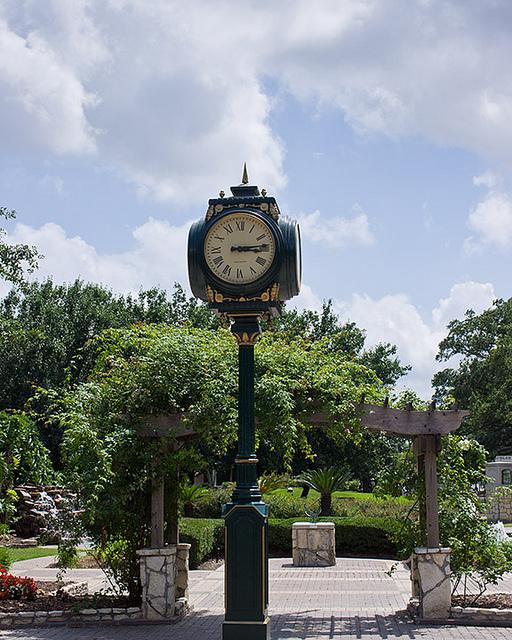What time is shown on the clock?
Be succinct. 3:15. What color are the flowers on the floor on the left of the clock?
Write a very short answer. Red. What color is the clock?
Write a very short answer. Green. 